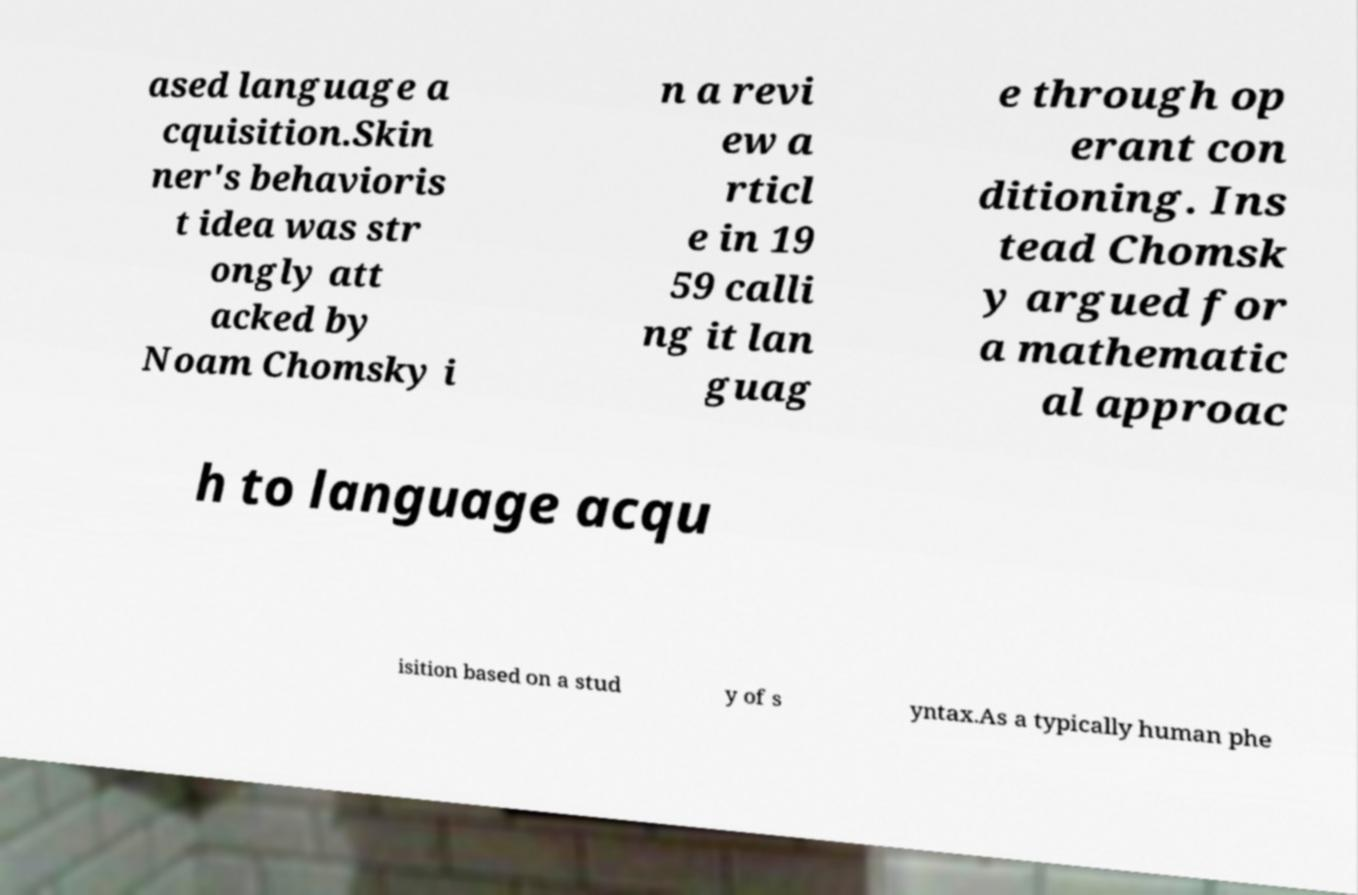Can you accurately transcribe the text from the provided image for me? ased language a cquisition.Skin ner's behavioris t idea was str ongly att acked by Noam Chomsky i n a revi ew a rticl e in 19 59 calli ng it lan guag e through op erant con ditioning. Ins tead Chomsk y argued for a mathematic al approac h to language acqu isition based on a stud y of s yntax.As a typically human phe 